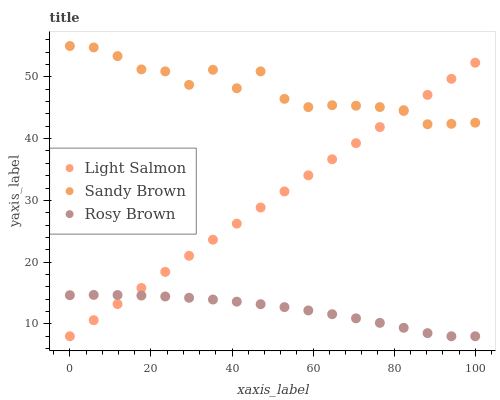Does Rosy Brown have the minimum area under the curve?
Answer yes or no. Yes. Does Sandy Brown have the maximum area under the curve?
Answer yes or no. Yes. Does Sandy Brown have the minimum area under the curve?
Answer yes or no. No. Does Rosy Brown have the maximum area under the curve?
Answer yes or no. No. Is Light Salmon the smoothest?
Answer yes or no. Yes. Is Sandy Brown the roughest?
Answer yes or no. Yes. Is Rosy Brown the smoothest?
Answer yes or no. No. Is Rosy Brown the roughest?
Answer yes or no. No. Does Light Salmon have the lowest value?
Answer yes or no. Yes. Does Sandy Brown have the lowest value?
Answer yes or no. No. Does Sandy Brown have the highest value?
Answer yes or no. Yes. Does Rosy Brown have the highest value?
Answer yes or no. No. Is Rosy Brown less than Sandy Brown?
Answer yes or no. Yes. Is Sandy Brown greater than Rosy Brown?
Answer yes or no. Yes. Does Rosy Brown intersect Light Salmon?
Answer yes or no. Yes. Is Rosy Brown less than Light Salmon?
Answer yes or no. No. Is Rosy Brown greater than Light Salmon?
Answer yes or no. No. Does Rosy Brown intersect Sandy Brown?
Answer yes or no. No. 